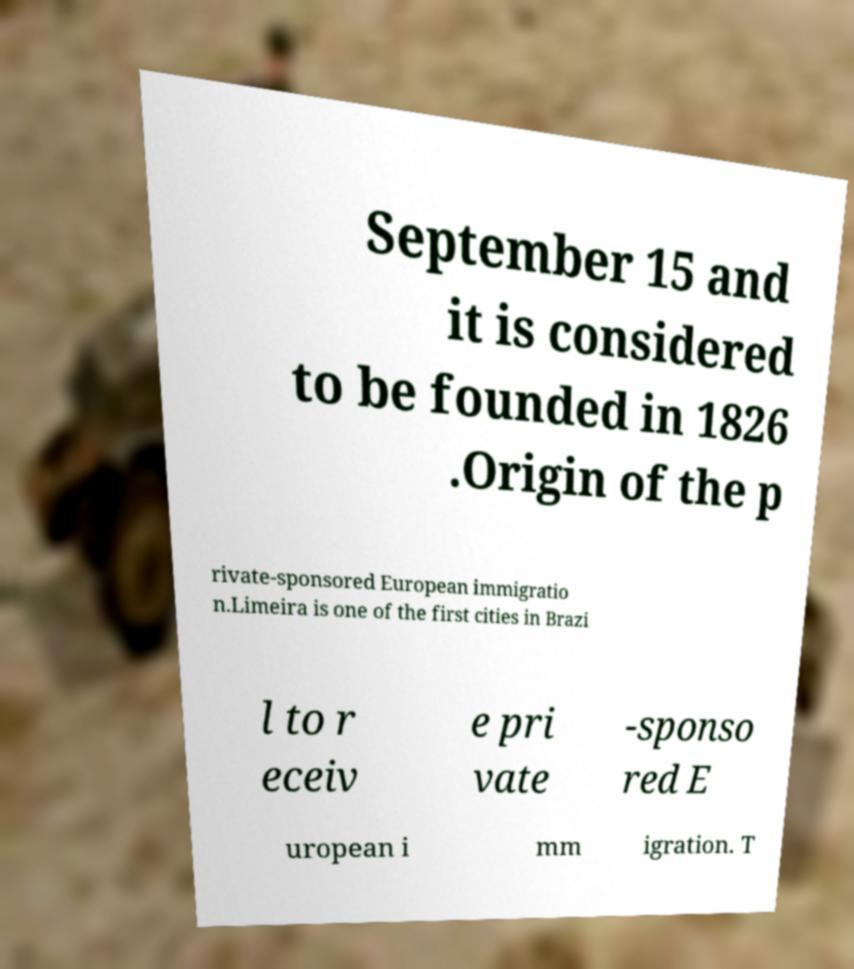There's text embedded in this image that I need extracted. Can you transcribe it verbatim? September 15 and it is considered to be founded in 1826 .Origin of the p rivate-sponsored European immigratio n.Limeira is one of the first cities in Brazi l to r eceiv e pri vate -sponso red E uropean i mm igration. T 